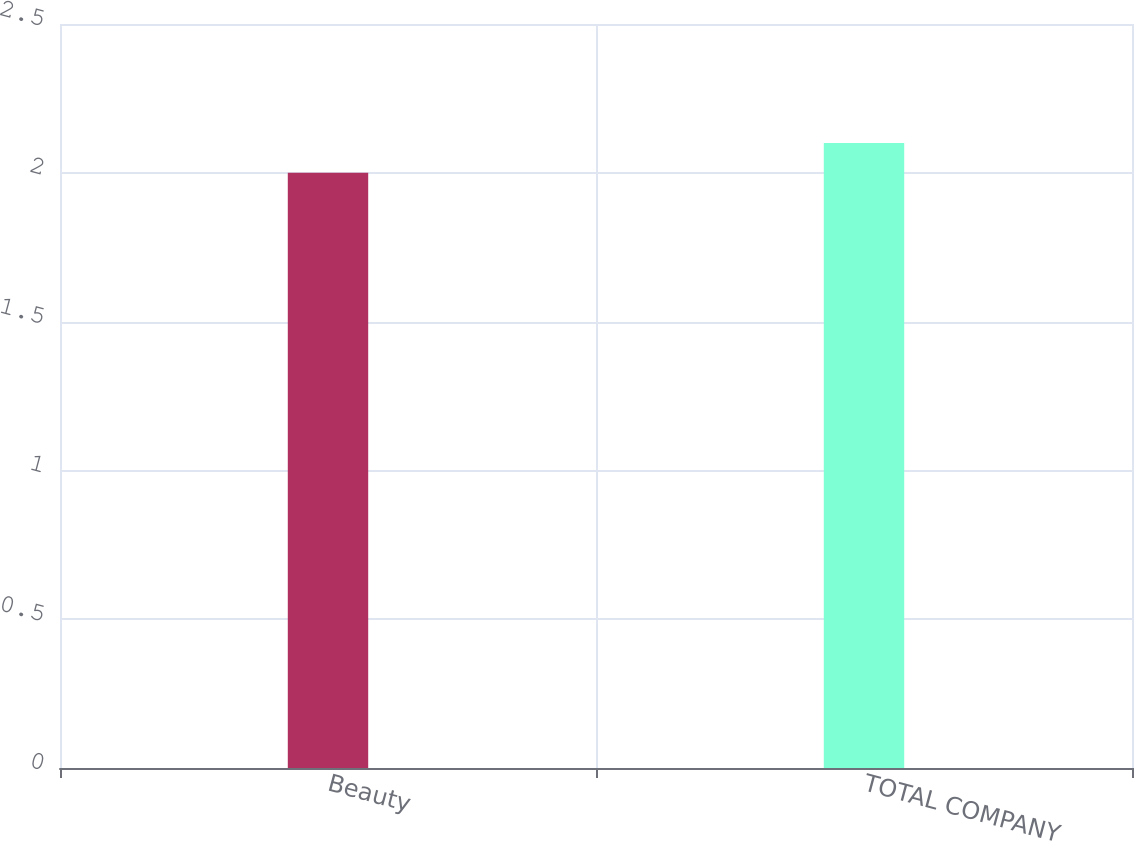Convert chart to OTSL. <chart><loc_0><loc_0><loc_500><loc_500><bar_chart><fcel>Beauty<fcel>TOTAL COMPANY<nl><fcel>2<fcel>2.1<nl></chart> 